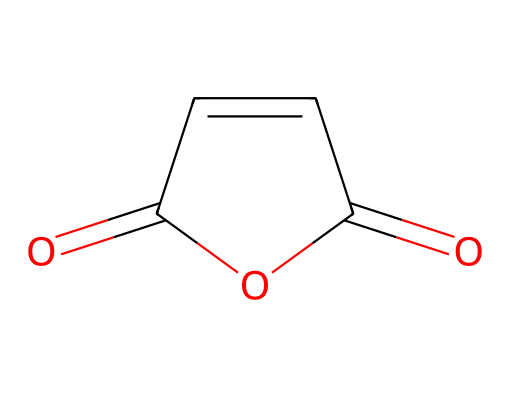how many carbon atoms are in this structure? The SMILES representation indicates the presence of C atoms. Counting the 'C' symbols, we find there are four carbon atoms present in the structure.
Answer: four how many oxygen atoms are present in this molecule? In the SMILES structure, the 'O' symbols represent oxygen atoms. There are three instances of 'O', which indicates that there are three oxygen atoms in total.
Answer: three what is the common name of this compound? This compound is known as maleic anhydride, which is a widely recognized name in chemistry for this specific chemical structure based on its properties and reactions.
Answer: maleic anhydride what type of functional groups are present in maleic anhydride? By examining the SMILES representation, we can note the presence of two carbonyl (C=O) groups and an anhydride functional group due to the cyclic structure of the molecule.
Answer: anhydride what is the degree of unsaturation in this structure? To calculate the degree of unsaturation, we consider the number of rings and multiple bonds. Here, there are two double bonds (the two C=O) and one ring structure, resulting in a degree of unsaturation of three.
Answer: three is maleic anhydride a solid or liquid at room temperature? Based on the properties of maleic anhydride and standard data, it is a solid at room temperature, typically characterized by its crystalline form.
Answer: solid does maleic anhydride have applications in biodegradable materials? Maleic anhydride is known for its use in polymer chemistry, particularly in creating biodegradable plastics and other materials due to its reactivity and ability to interact with various polymers.
Answer: yes 